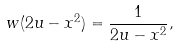Convert formula to latex. <formula><loc_0><loc_0><loc_500><loc_500>w ( 2 u - x ^ { 2 } ) = \frac { 1 } { 2 u - x ^ { 2 } } ,</formula> 